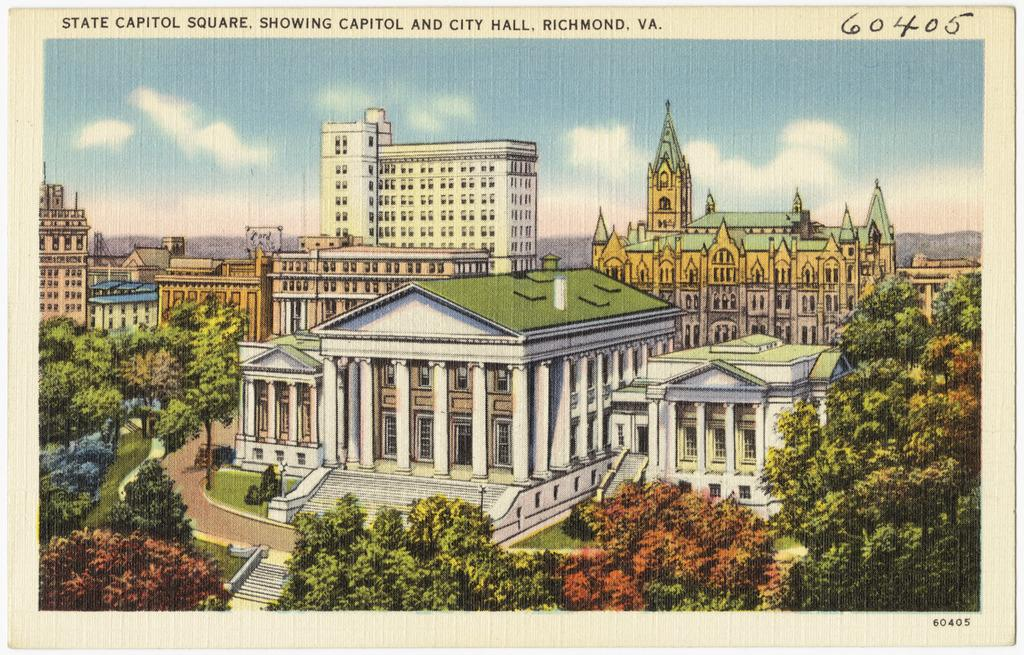What type of structures can be seen in the image? There are buildings in the image. What other natural elements are present in the image? There are trees in the image. What can be seen in the sky in the image? There are clouds in the sky in the image. What is written or displayed at the top of the image? There is text at the top of the image. How many planes are flying over the buildings in the image? There are no planes visible in the image; it only shows buildings, trees, clouds, and text. Can you describe the man standing next to the trees in the image? There is no man present in the image; it only features buildings, trees, clouds, and text. 